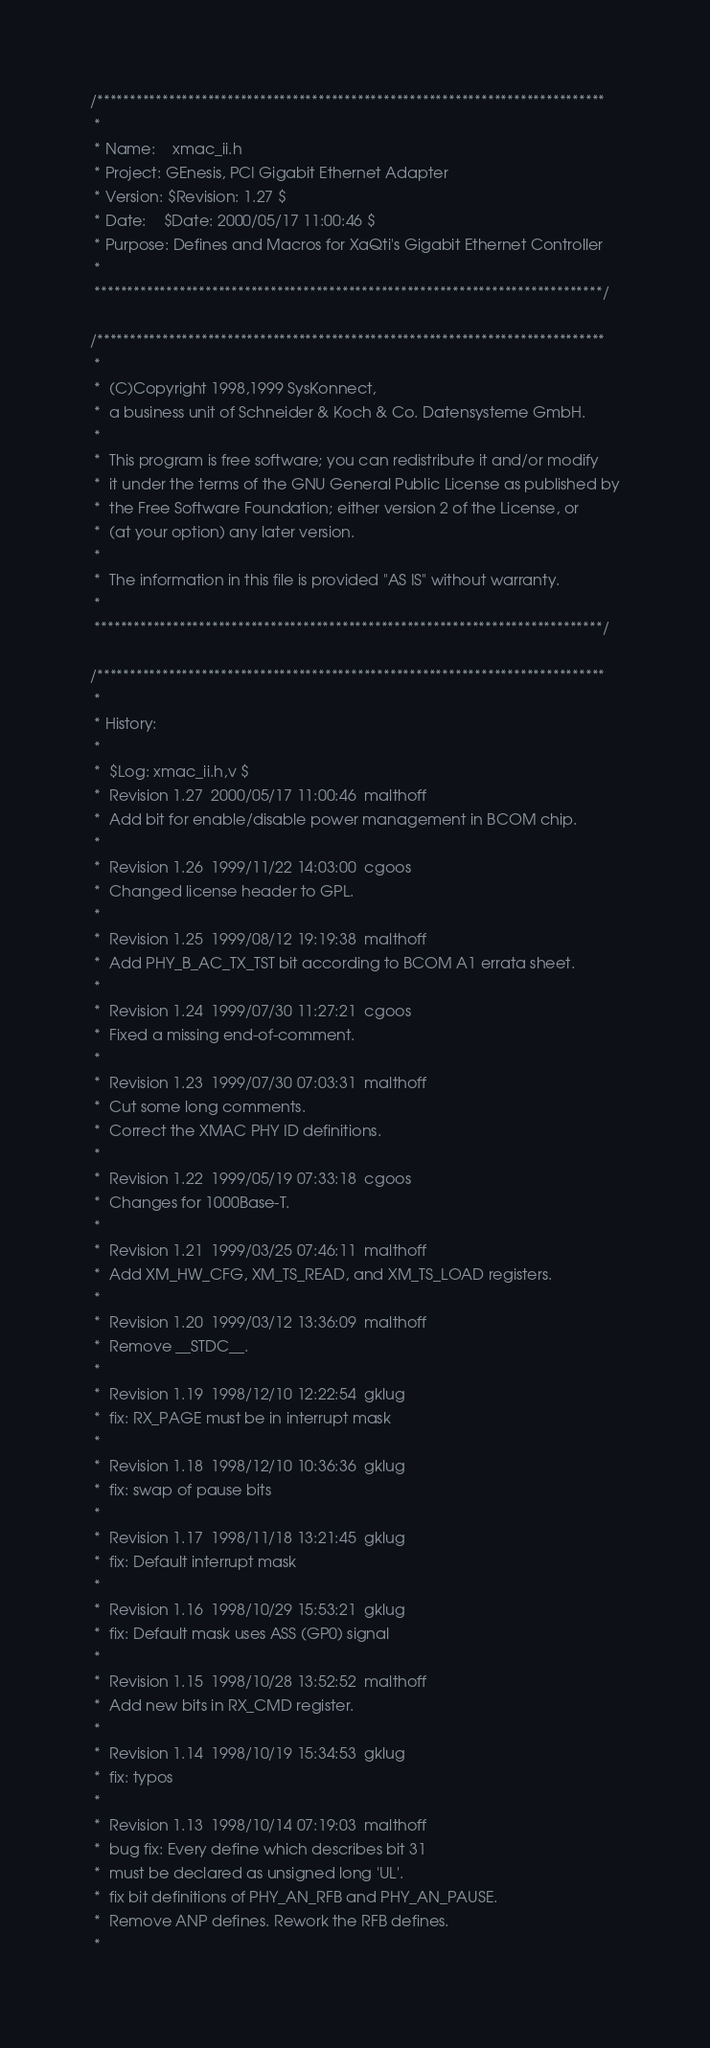<code> <loc_0><loc_0><loc_500><loc_500><_C_>/******************************************************************************
 *
 * Name:	xmac_ii.h
 * Project:	GEnesis, PCI Gigabit Ethernet Adapter
 * Version:	$Revision: 1.27 $
 * Date:	$Date: 2000/05/17 11:00:46 $
 * Purpose:	Defines and Macros for XaQti's Gigabit Ethernet Controller
 *
 ******************************************************************************/

/******************************************************************************
 *
 *	(C)Copyright 1998,1999 SysKonnect,
 *	a business unit of Schneider & Koch & Co. Datensysteme GmbH.
 *
 *	This program is free software; you can redistribute it and/or modify
 *	it under the terms of the GNU General Public License as published by
 *	the Free Software Foundation; either version 2 of the License, or
 *	(at your option) any later version.
 *
 *	The information in this file is provided "AS IS" without warranty.
 *
 ******************************************************************************/

/******************************************************************************
 *
 * History:
 *
 *	$Log: xmac_ii.h,v $
 *	Revision 1.27  2000/05/17 11:00:46  malthoff
 *	Add bit for enable/disable power management in BCOM chip.
 *	
 *	Revision 1.26  1999/11/22 14:03:00  cgoos
 *	Changed license header to GPL.
 *	
 *	Revision 1.25  1999/08/12 19:19:38  malthoff
 *	Add PHY_B_AC_TX_TST bit according to BCOM A1 errata sheet.
 *	
 *	Revision 1.24  1999/07/30 11:27:21  cgoos
 *	Fixed a missing end-of-comment.
 *	
 *	Revision 1.23  1999/07/30 07:03:31  malthoff
 *	Cut some long comments.
 *	Correct the XMAC PHY ID definitions.
 *	
 *	Revision 1.22  1999/05/19 07:33:18  cgoos
 *	Changes for 1000Base-T.
 *	
 *	Revision 1.21  1999/03/25 07:46:11  malthoff
 *	Add XM_HW_CFG, XM_TS_READ, and XM_TS_LOAD registers.
 *	
 *	Revision 1.20  1999/03/12 13:36:09  malthoff
 *	Remove __STDC__.
 *
 *	Revision 1.19  1998/12/10 12:22:54  gklug
 *	fix: RX_PAGE must be in interrupt mask
 *
 *	Revision 1.18  1998/12/10 10:36:36  gklug
 *	fix: swap of pause bits
 *
 *	Revision 1.17  1998/11/18 13:21:45  gklug
 *	fix: Default interrupt mask
 *
 *	Revision 1.16  1998/10/29 15:53:21  gklug
 *	fix: Default mask uses ASS (GP0) signal
 *
 *	Revision 1.15  1998/10/28 13:52:52  malthoff
 *	Add new bits in RX_CMD register.
 *
 *	Revision 1.14  1998/10/19 15:34:53  gklug
 *	fix: typos
 *
 *	Revision 1.13  1998/10/14 07:19:03  malthoff
 *	bug fix: Every define which describes bit 31
 *	must be declared as unsigned long 'UL'.
 *	fix bit definitions of PHY_AN_RFB and PHY_AN_PAUSE.
 *	Remove ANP defines. Rework the RFB defines.
 *</code> 